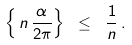Convert formula to latex. <formula><loc_0><loc_0><loc_500><loc_500>\left \{ \, n \, \frac { \alpha } { 2 \pi } \right \} \ \leq \ \frac { 1 } { n } \, .</formula> 